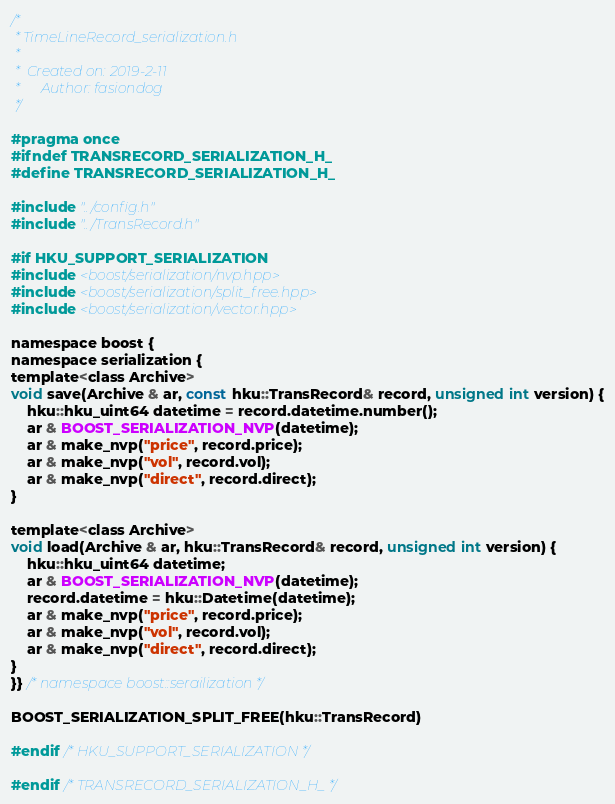Convert code to text. <code><loc_0><loc_0><loc_500><loc_500><_C_>/*
 * TimeLineRecord_serialization.h
 *
 *  Created on: 2019-2-11
 *      Author: fasiondog
 */

#pragma once
#ifndef TRANSRECORD_SERIALIZATION_H_
#define TRANSRECORD_SERIALIZATION_H_

#include "../config.h"
#include "../TransRecord.h"

#if HKU_SUPPORT_SERIALIZATION
#include <boost/serialization/nvp.hpp>
#include <boost/serialization/split_free.hpp>
#include <boost/serialization/vector.hpp>

namespace boost {
namespace serialization {
template<class Archive>
void save(Archive & ar, const hku::TransRecord& record, unsigned int version) {
    hku::hku_uint64 datetime = record.datetime.number();
    ar & BOOST_SERIALIZATION_NVP(datetime);
    ar & make_nvp("price", record.price);
    ar & make_nvp("vol", record.vol);
    ar & make_nvp("direct", record.direct);
}

template<class Archive>
void load(Archive & ar, hku::TransRecord& record, unsigned int version) {
    hku::hku_uint64 datetime;
    ar & BOOST_SERIALIZATION_NVP(datetime);
    record.datetime = hku::Datetime(datetime);
    ar & make_nvp("price", record.price);
    ar & make_nvp("vol", record.vol);
    ar & make_nvp("direct", record.direct);
}
}} /* namespace boost::serailization */

BOOST_SERIALIZATION_SPLIT_FREE(hku::TransRecord)

#endif /* HKU_SUPPORT_SERIALIZATION */

#endif /* TRANSRECORD_SERIALIZATION_H_ */
</code> 